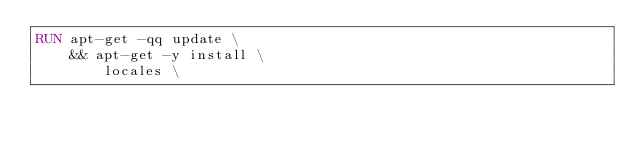<code> <loc_0><loc_0><loc_500><loc_500><_Dockerfile_>RUN apt-get -qq update \
    && apt-get -y install \
        locales \</code> 